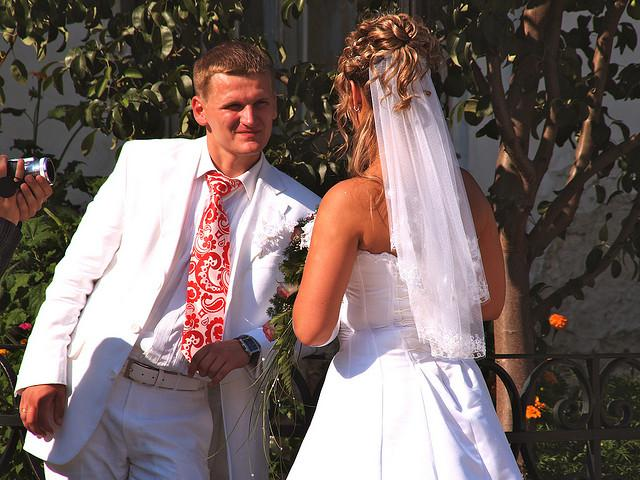What life event are they in the middle of celebrating?

Choices:
A) anniversary
B) graduation
C) marriage
D) pregnancy marriage 